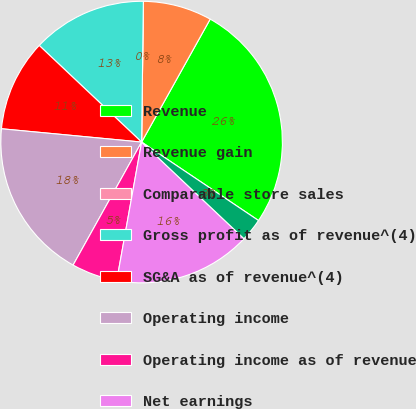Convert chart to OTSL. <chart><loc_0><loc_0><loc_500><loc_500><pie_chart><fcel>Revenue<fcel>Revenue gain<fcel>Comparable store sales<fcel>Gross profit as of revenue^(4)<fcel>SG&A as of revenue^(4)<fcel>Operating income<fcel>Operating income as of revenue<fcel>Net earnings<fcel>Diluted earnings per share<nl><fcel>26.31%<fcel>7.9%<fcel>0.0%<fcel>13.16%<fcel>10.53%<fcel>18.42%<fcel>5.26%<fcel>15.79%<fcel>2.63%<nl></chart> 